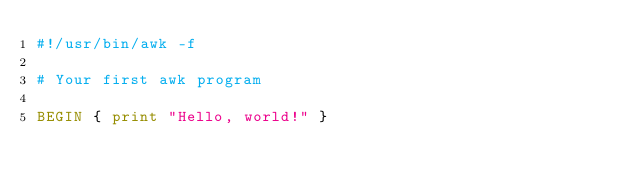<code> <loc_0><loc_0><loc_500><loc_500><_Awk_>#!/usr/bin/awk -f

# Your first awk program

BEGIN { print "Hello, world!" }
</code> 